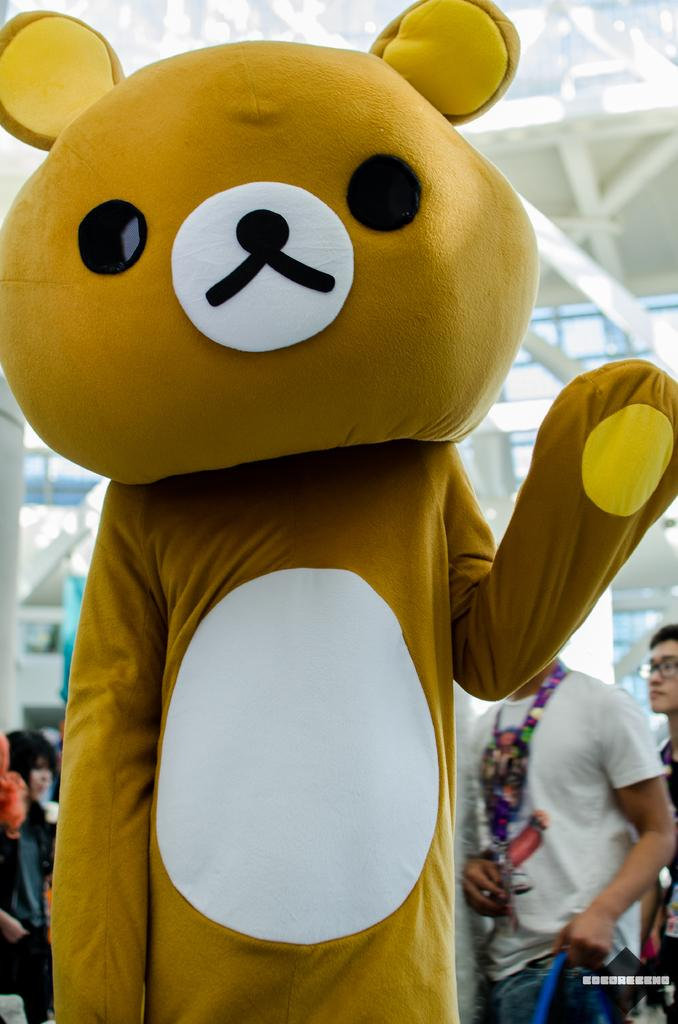What is the person in the image wearing? The person in the image is wearing a different costume. Are there any other people in the image? Yes, there are people standing behind the person in the costume. What type of blade is the person holding in the image? There is no blade present in the image. Can you see any hens in the image? No, there are no hens present in the image. 